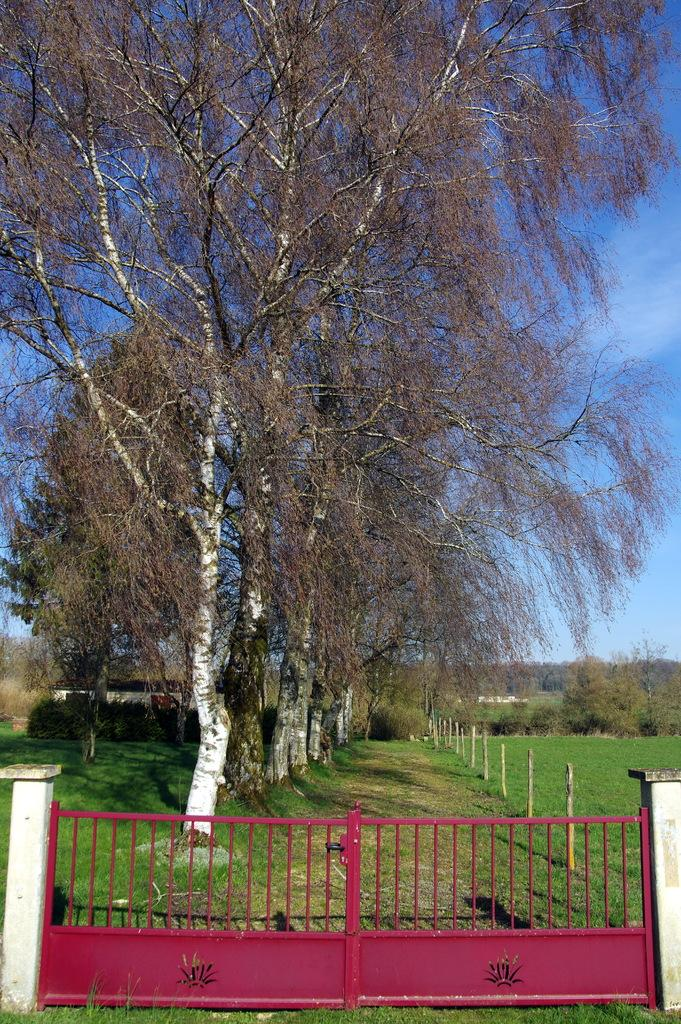What is the main structure in the image? There is a gate in the image. How are the poles supporting the gate? The gate is attached to two white color poles. What can be seen in the background of the image? There are poles, trees, plants, grass, and the sky visible in the background of the image. What is the color of the sky in the image? The sky is blue in the image. Are there any clouds in the sky? Yes, there are clouds in the sky. What type of seed is being planted by the actor in the image? There is no actor or seed present in the image. The image features a gate with white poles and a background that includes trees, plants, grass, and a blue sky with clouds. 